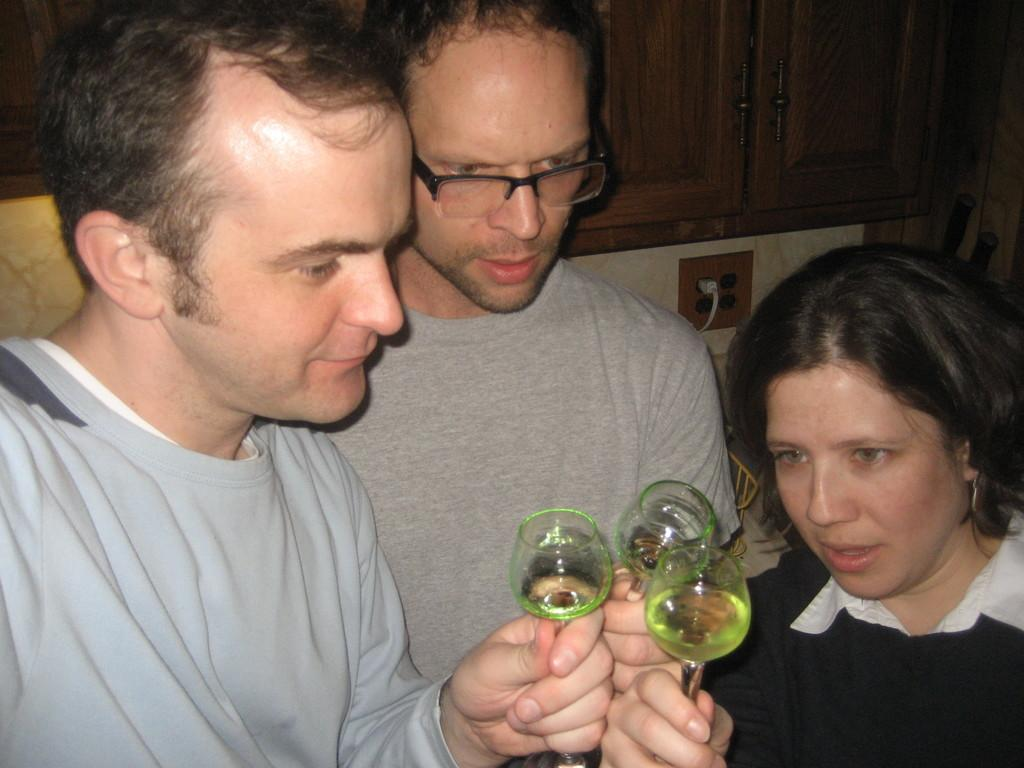How many people are in the image? There are two men and a woman in the image. What are the people holding in their hands? The woman is holding a glass with her hand, and one of the men is holding a glass with his hand. Can you describe the appearance of the other man? The other man is wearing spectacles. What type of furniture is present in the image? There is a cupboard in the image. What type of history is being discussed by the people in the image? There is no indication of a discussion about history in the image. Can you tell me how many cattle are visible in the image? There are no cattle present in the image. 